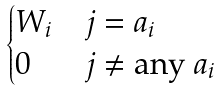Convert formula to latex. <formula><loc_0><loc_0><loc_500><loc_500>\begin{cases} W _ { i } & j = a _ { i } \\ 0 & j \neq \text {any } a _ { i } \\ \end{cases}</formula> 